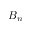Convert formula to latex. <formula><loc_0><loc_0><loc_500><loc_500>B _ { n }</formula> 